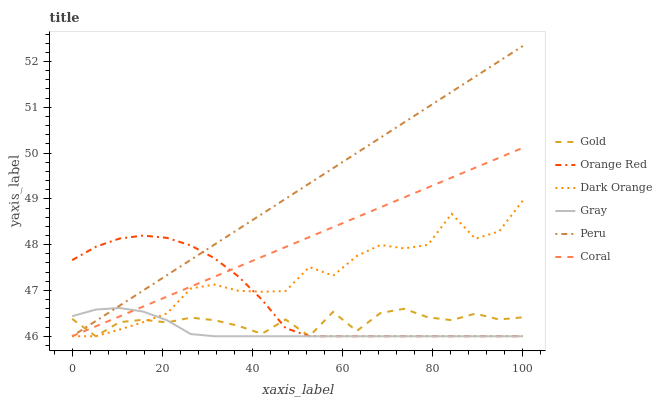Does Gray have the minimum area under the curve?
Answer yes or no. Yes. Does Peru have the maximum area under the curve?
Answer yes or no. Yes. Does Gold have the minimum area under the curve?
Answer yes or no. No. Does Gold have the maximum area under the curve?
Answer yes or no. No. Is Peru the smoothest?
Answer yes or no. Yes. Is Dark Orange the roughest?
Answer yes or no. Yes. Is Gold the smoothest?
Answer yes or no. No. Is Gold the roughest?
Answer yes or no. No. Does Dark Orange have the lowest value?
Answer yes or no. Yes. Does Peru have the highest value?
Answer yes or no. Yes. Does Gray have the highest value?
Answer yes or no. No. Does Peru intersect Gray?
Answer yes or no. Yes. Is Peru less than Gray?
Answer yes or no. No. Is Peru greater than Gray?
Answer yes or no. No. 